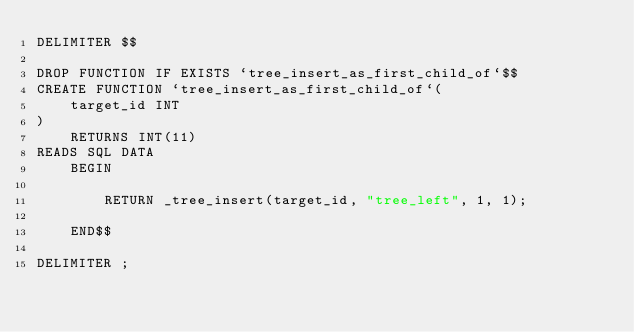<code> <loc_0><loc_0><loc_500><loc_500><_SQL_>DELIMITER $$

DROP FUNCTION IF EXISTS `tree_insert_as_first_child_of`$$
CREATE FUNCTION `tree_insert_as_first_child_of`(
		target_id INT
)
		RETURNS INT(11)
READS SQL DATA
		BEGIN

				RETURN _tree_insert(target_id, "tree_left", 1, 1);

		END$$

DELIMITER ;</code> 